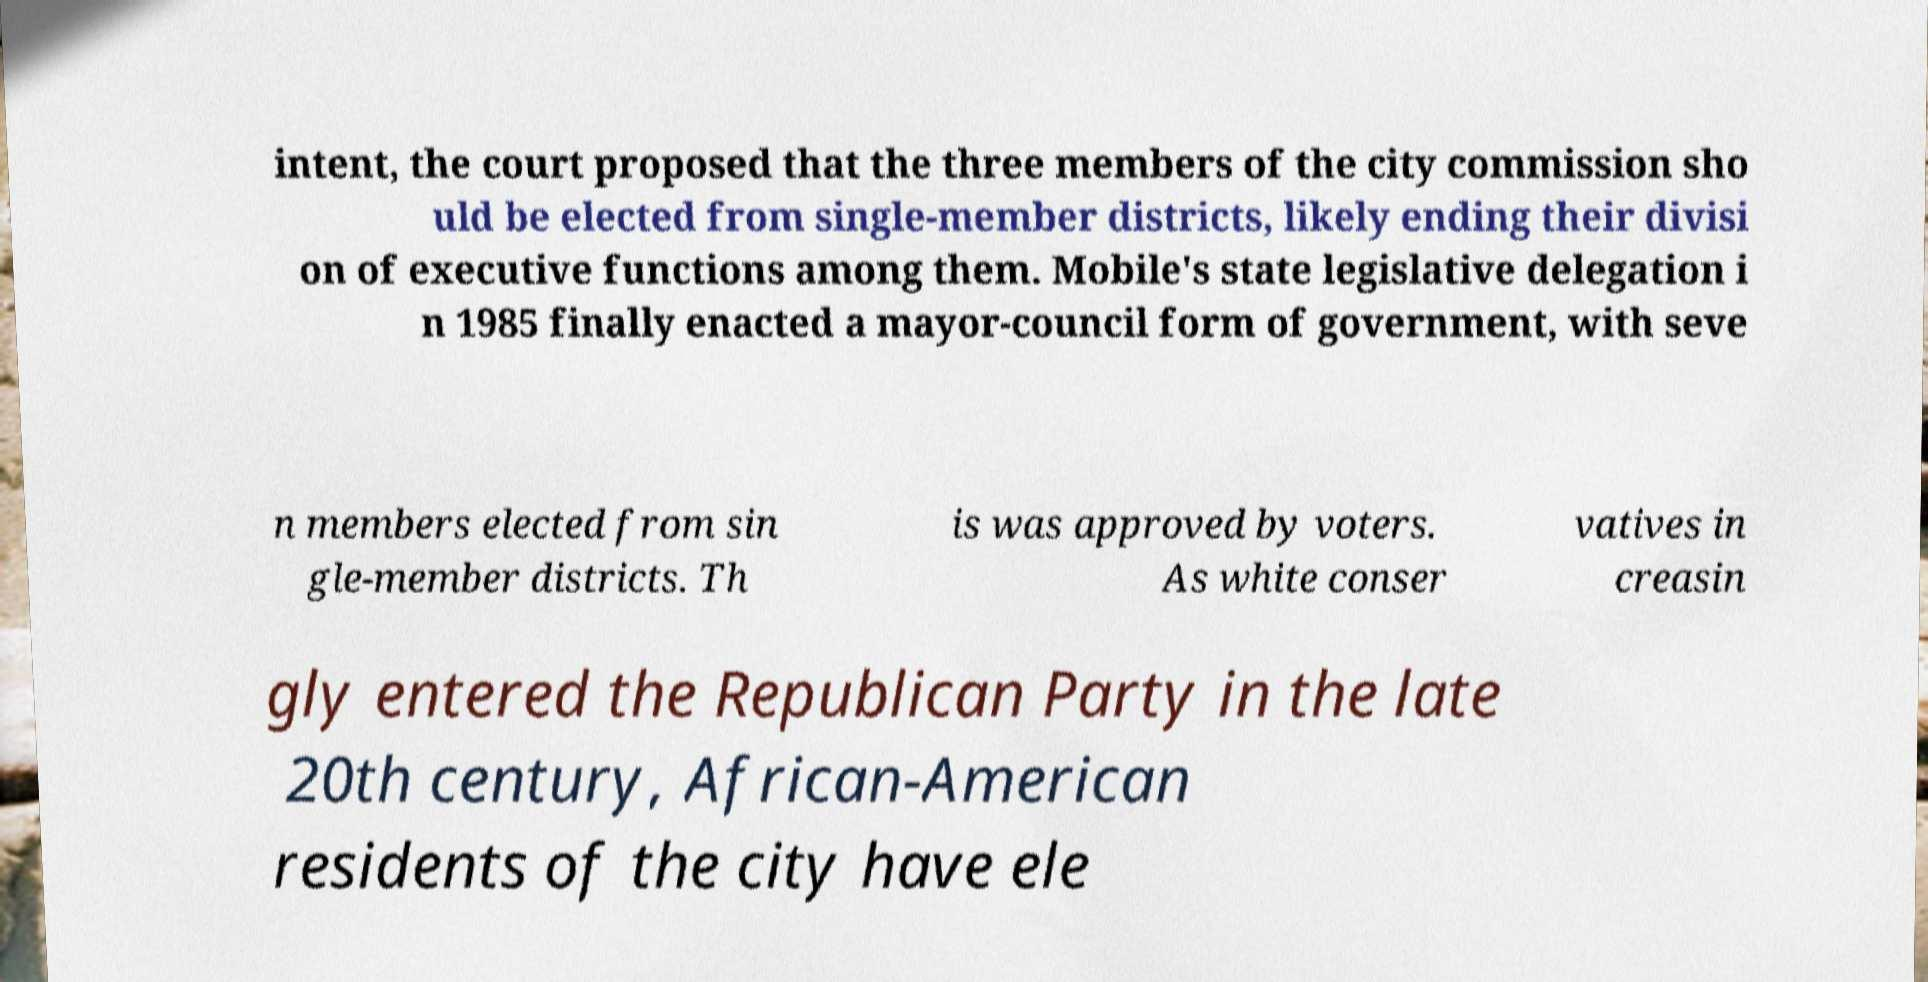Could you extract and type out the text from this image? intent, the court proposed that the three members of the city commission sho uld be elected from single-member districts, likely ending their divisi on of executive functions among them. Mobile's state legislative delegation i n 1985 finally enacted a mayor-council form of government, with seve n members elected from sin gle-member districts. Th is was approved by voters. As white conser vatives in creasin gly entered the Republican Party in the late 20th century, African-American residents of the city have ele 